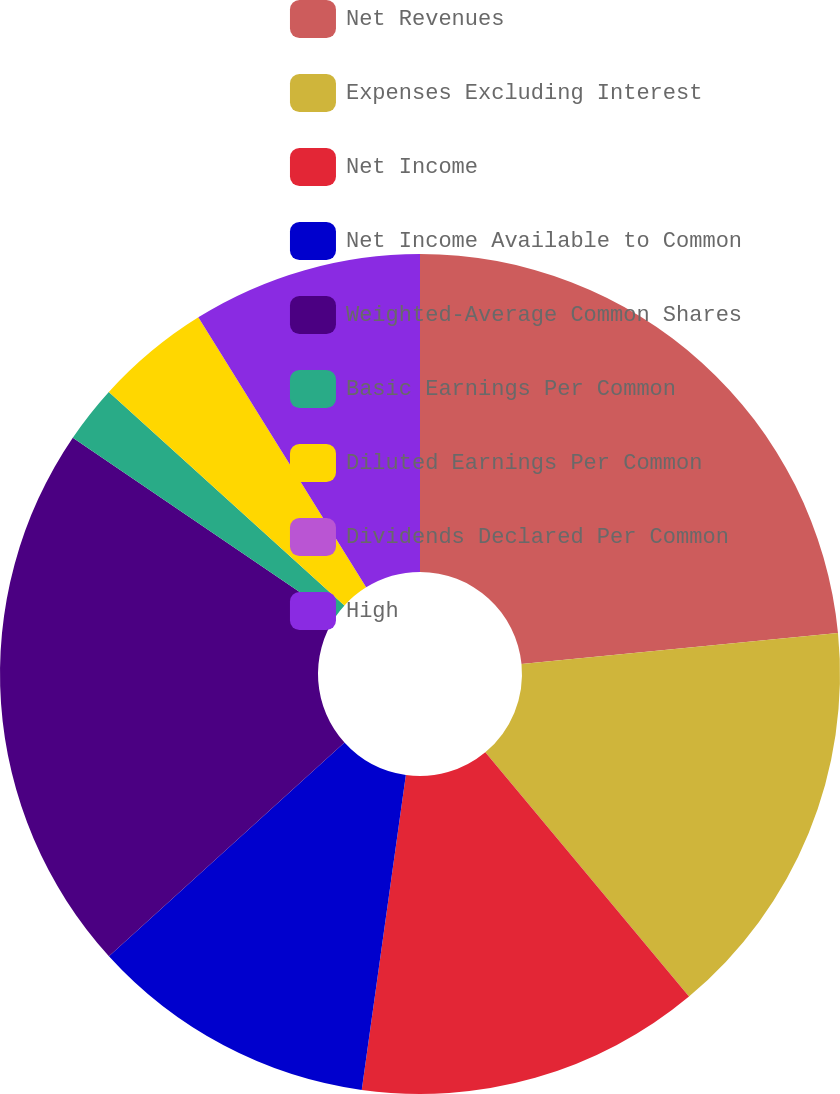Convert chart. <chart><loc_0><loc_0><loc_500><loc_500><pie_chart><fcel>Net Revenues<fcel>Expenses Excluding Interest<fcel>Net Income<fcel>Net Income Available to Common<fcel>Weighted-Average Common Shares<fcel>Basic Earnings Per Common<fcel>Diluted Earnings Per Common<fcel>Dividends Declared Per Common<fcel>High<nl><fcel>23.45%<fcel>15.49%<fcel>13.28%<fcel>11.06%<fcel>21.24%<fcel>2.21%<fcel>4.43%<fcel>0.0%<fcel>8.85%<nl></chart> 